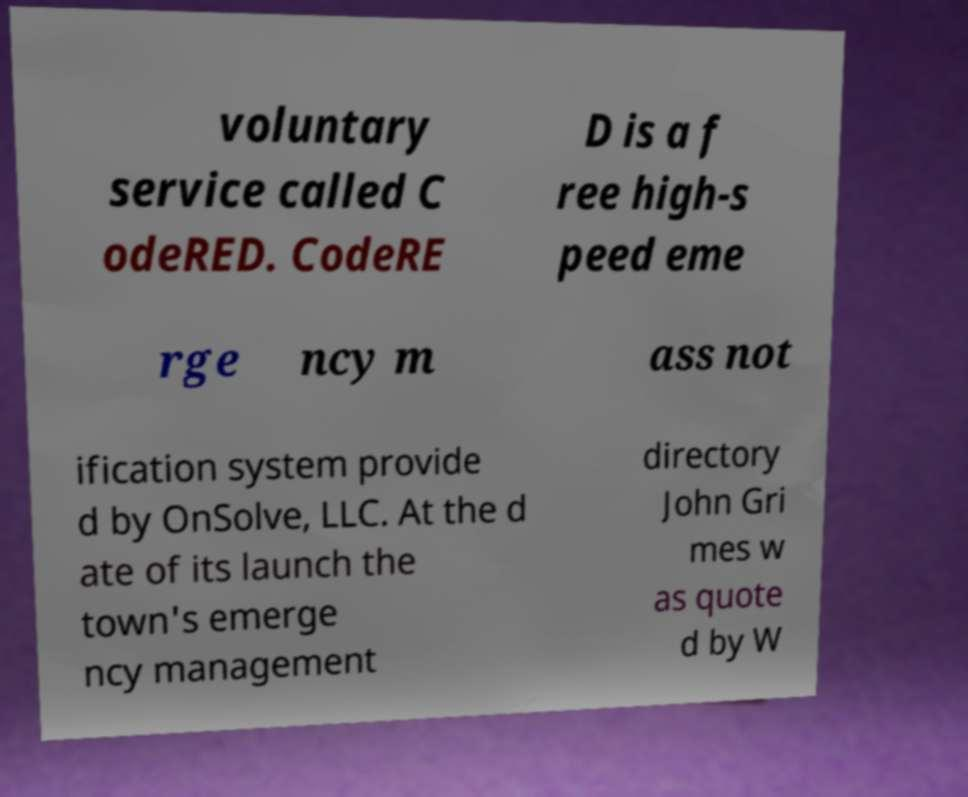There's text embedded in this image that I need extracted. Can you transcribe it verbatim? voluntary service called C odeRED. CodeRE D is a f ree high-s peed eme rge ncy m ass not ification system provide d by OnSolve, LLC. At the d ate of its launch the town's emerge ncy management directory John Gri mes w as quote d by W 